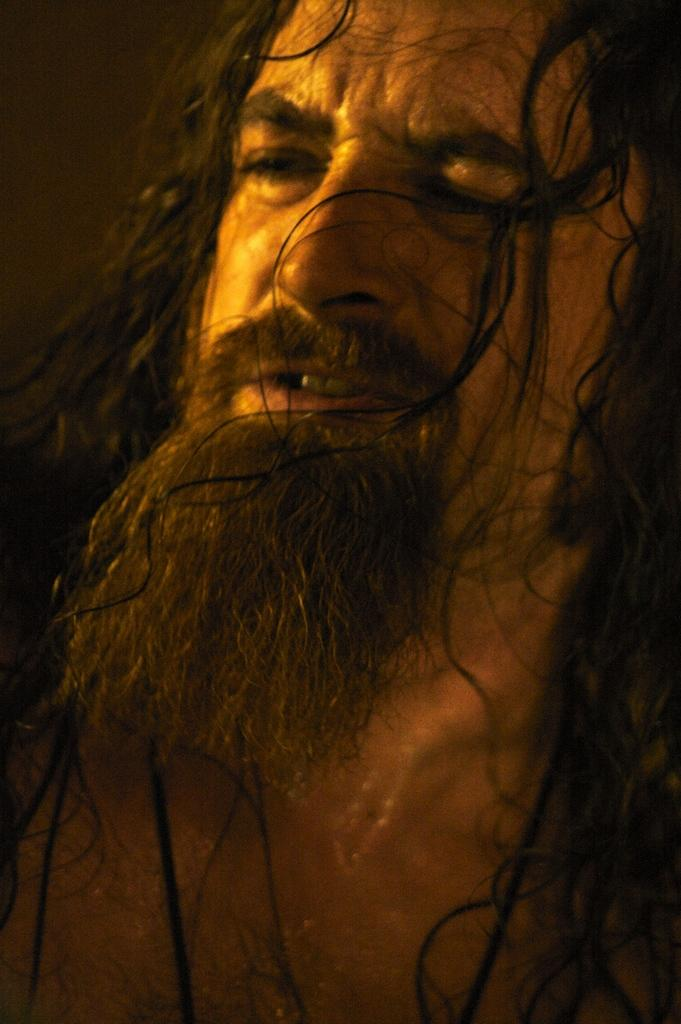What is present in the image? There is a person in the image. Can you describe the person's appearance? The person has long hair and a beard. What is the price of the person's beard in the image? There is no price associated with the person's beard in the image, as it is not a product for sale. 